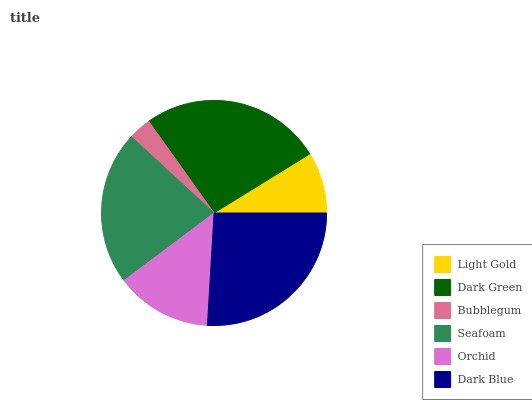Is Bubblegum the minimum?
Answer yes or no. Yes. Is Dark Green the maximum?
Answer yes or no. Yes. Is Dark Green the minimum?
Answer yes or no. No. Is Bubblegum the maximum?
Answer yes or no. No. Is Dark Green greater than Bubblegum?
Answer yes or no. Yes. Is Bubblegum less than Dark Green?
Answer yes or no. Yes. Is Bubblegum greater than Dark Green?
Answer yes or no. No. Is Dark Green less than Bubblegum?
Answer yes or no. No. Is Seafoam the high median?
Answer yes or no. Yes. Is Orchid the low median?
Answer yes or no. Yes. Is Orchid the high median?
Answer yes or no. No. Is Dark Green the low median?
Answer yes or no. No. 